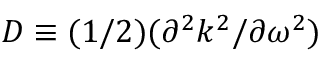<formula> <loc_0><loc_0><loc_500><loc_500>D \equiv ( 1 / 2 ) ( \partial ^ { 2 } k ^ { 2 } / \partial \omega ^ { 2 } )</formula> 